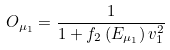Convert formula to latex. <formula><loc_0><loc_0><loc_500><loc_500>O _ { \mu _ { 1 } } = \frac { 1 } { 1 + f _ { 2 } \left ( E _ { \mu _ { 1 } } \right ) v _ { 1 } ^ { 2 } }</formula> 